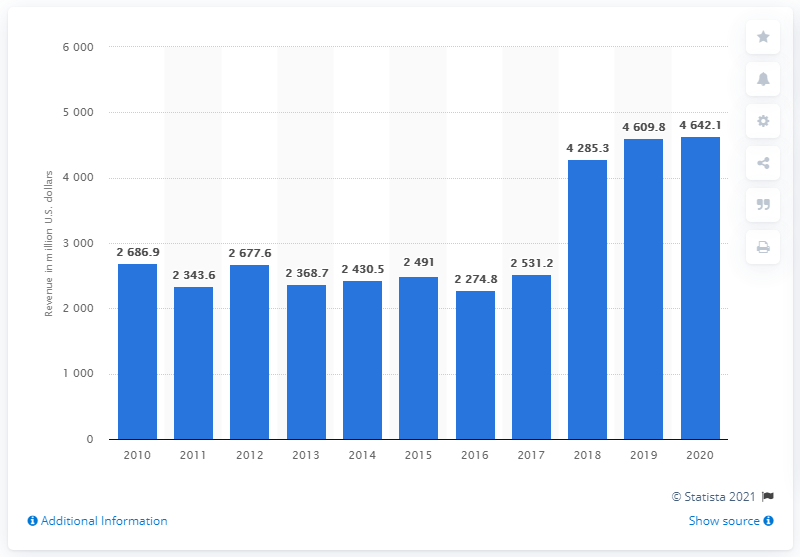List a handful of essential elements in this visual. In 2020, FMC Corporation generated a total revenue of approximately 4642.1 million dollars in the United States. 